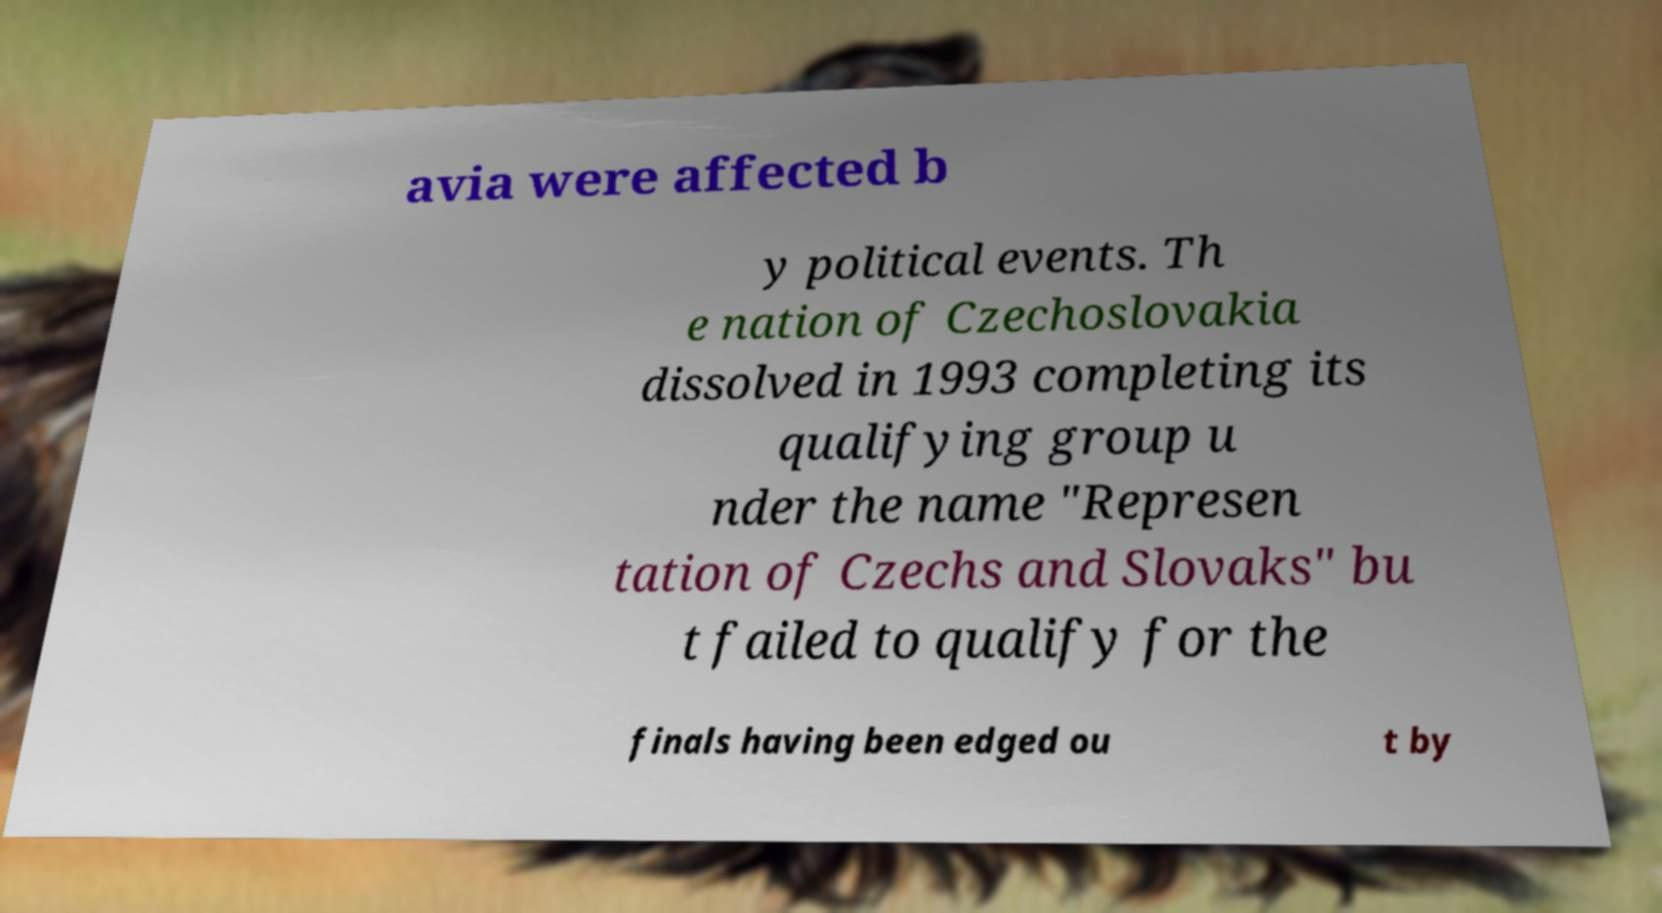For documentation purposes, I need the text within this image transcribed. Could you provide that? avia were affected b y political events. Th e nation of Czechoslovakia dissolved in 1993 completing its qualifying group u nder the name "Represen tation of Czechs and Slovaks" bu t failed to qualify for the finals having been edged ou t by 